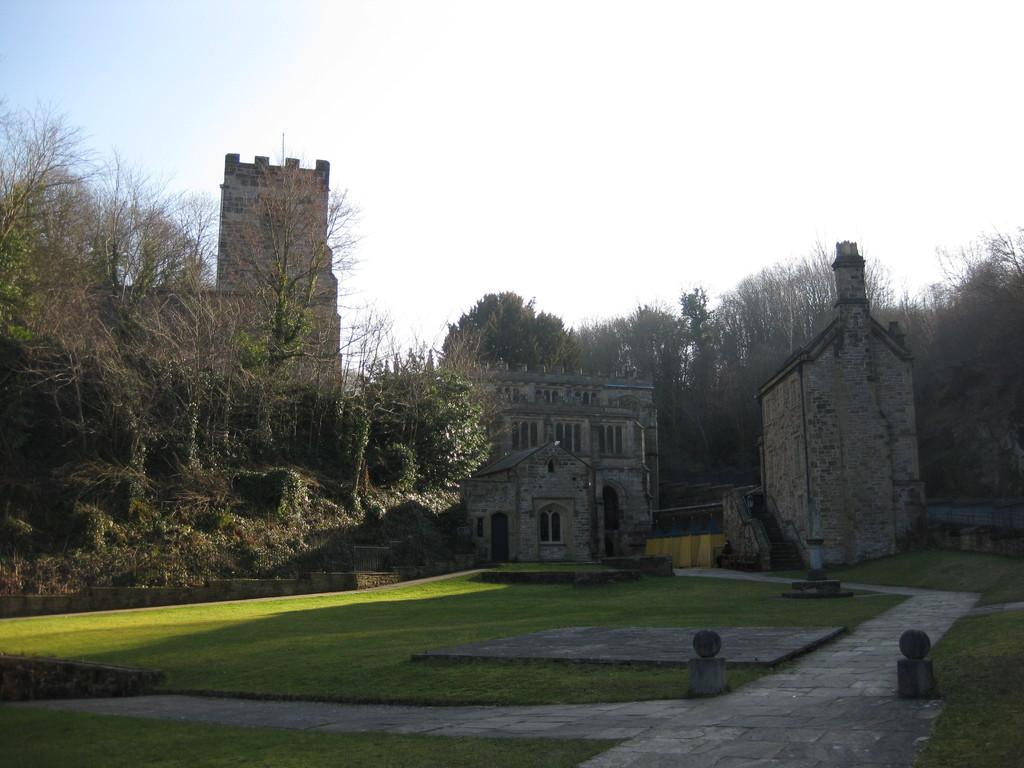What can be seen in the foreground of the image? There is a path and grasslands in the foreground of the image. What is located in the middle of the image? There are buildings and trees in the middle of the image. What is visible at the top of the image? The sky is visible at the top of the image. Can you hear the government discussing policies in the image? There is no audible discussion or reference to the government in the image; it is a visual representation of a scene. Is the cat visible in the image? There is no cat present in the image. 